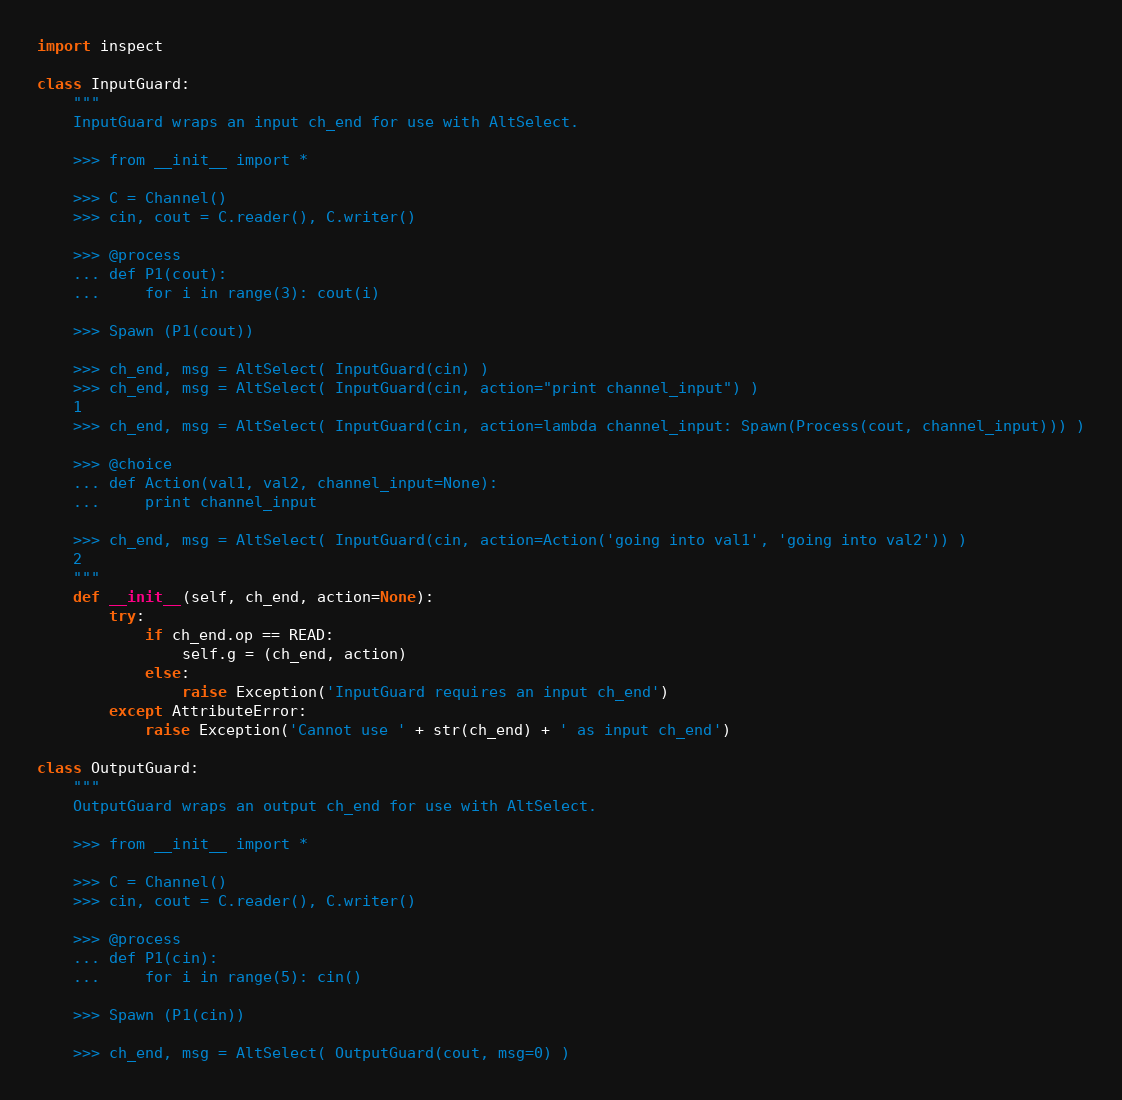Convert code to text. <code><loc_0><loc_0><loc_500><loc_500><_Python_>import inspect

class InputGuard:
    """
    InputGuard wraps an input ch_end for use with AltSelect.

    >>> from __init__ import *

    >>> C = Channel()
    >>> cin, cout = C.reader(), C.writer()

    >>> @process
    ... def P1(cout):
    ...     for i in range(3): cout(i)

    >>> Spawn (P1(cout))

    >>> ch_end, msg = AltSelect( InputGuard(cin) )
    >>> ch_end, msg = AltSelect( InputGuard(cin, action="print channel_input") )
    1
    >>> ch_end, msg = AltSelect( InputGuard(cin, action=lambda channel_input: Spawn(Process(cout, channel_input))) )
    
    >>> @choice
    ... def Action(val1, val2, channel_input=None):
    ...     print channel_input

    >>> ch_end, msg = AltSelect( InputGuard(cin, action=Action('going into val1', 'going into val2')) )
    2
    """
    def __init__(self, ch_end, action=None):
        try:
            if ch_end.op == READ:
                self.g = (ch_end, action)
            else:
                raise Exception('InputGuard requires an input ch_end')
        except AttributeError:
            raise Exception('Cannot use ' + str(ch_end) + ' as input ch_end')

class OutputGuard:
    """
    OutputGuard wraps an output ch_end for use with AltSelect.

    >>> from __init__ import *

    >>> C = Channel()
    >>> cin, cout = C.reader(), C.writer()

    >>> @process
    ... def P1(cin):
    ...     for i in range(5): cin()

    >>> Spawn (P1(cin))

    >>> ch_end, msg = AltSelect( OutputGuard(cout, msg=0) )</code> 